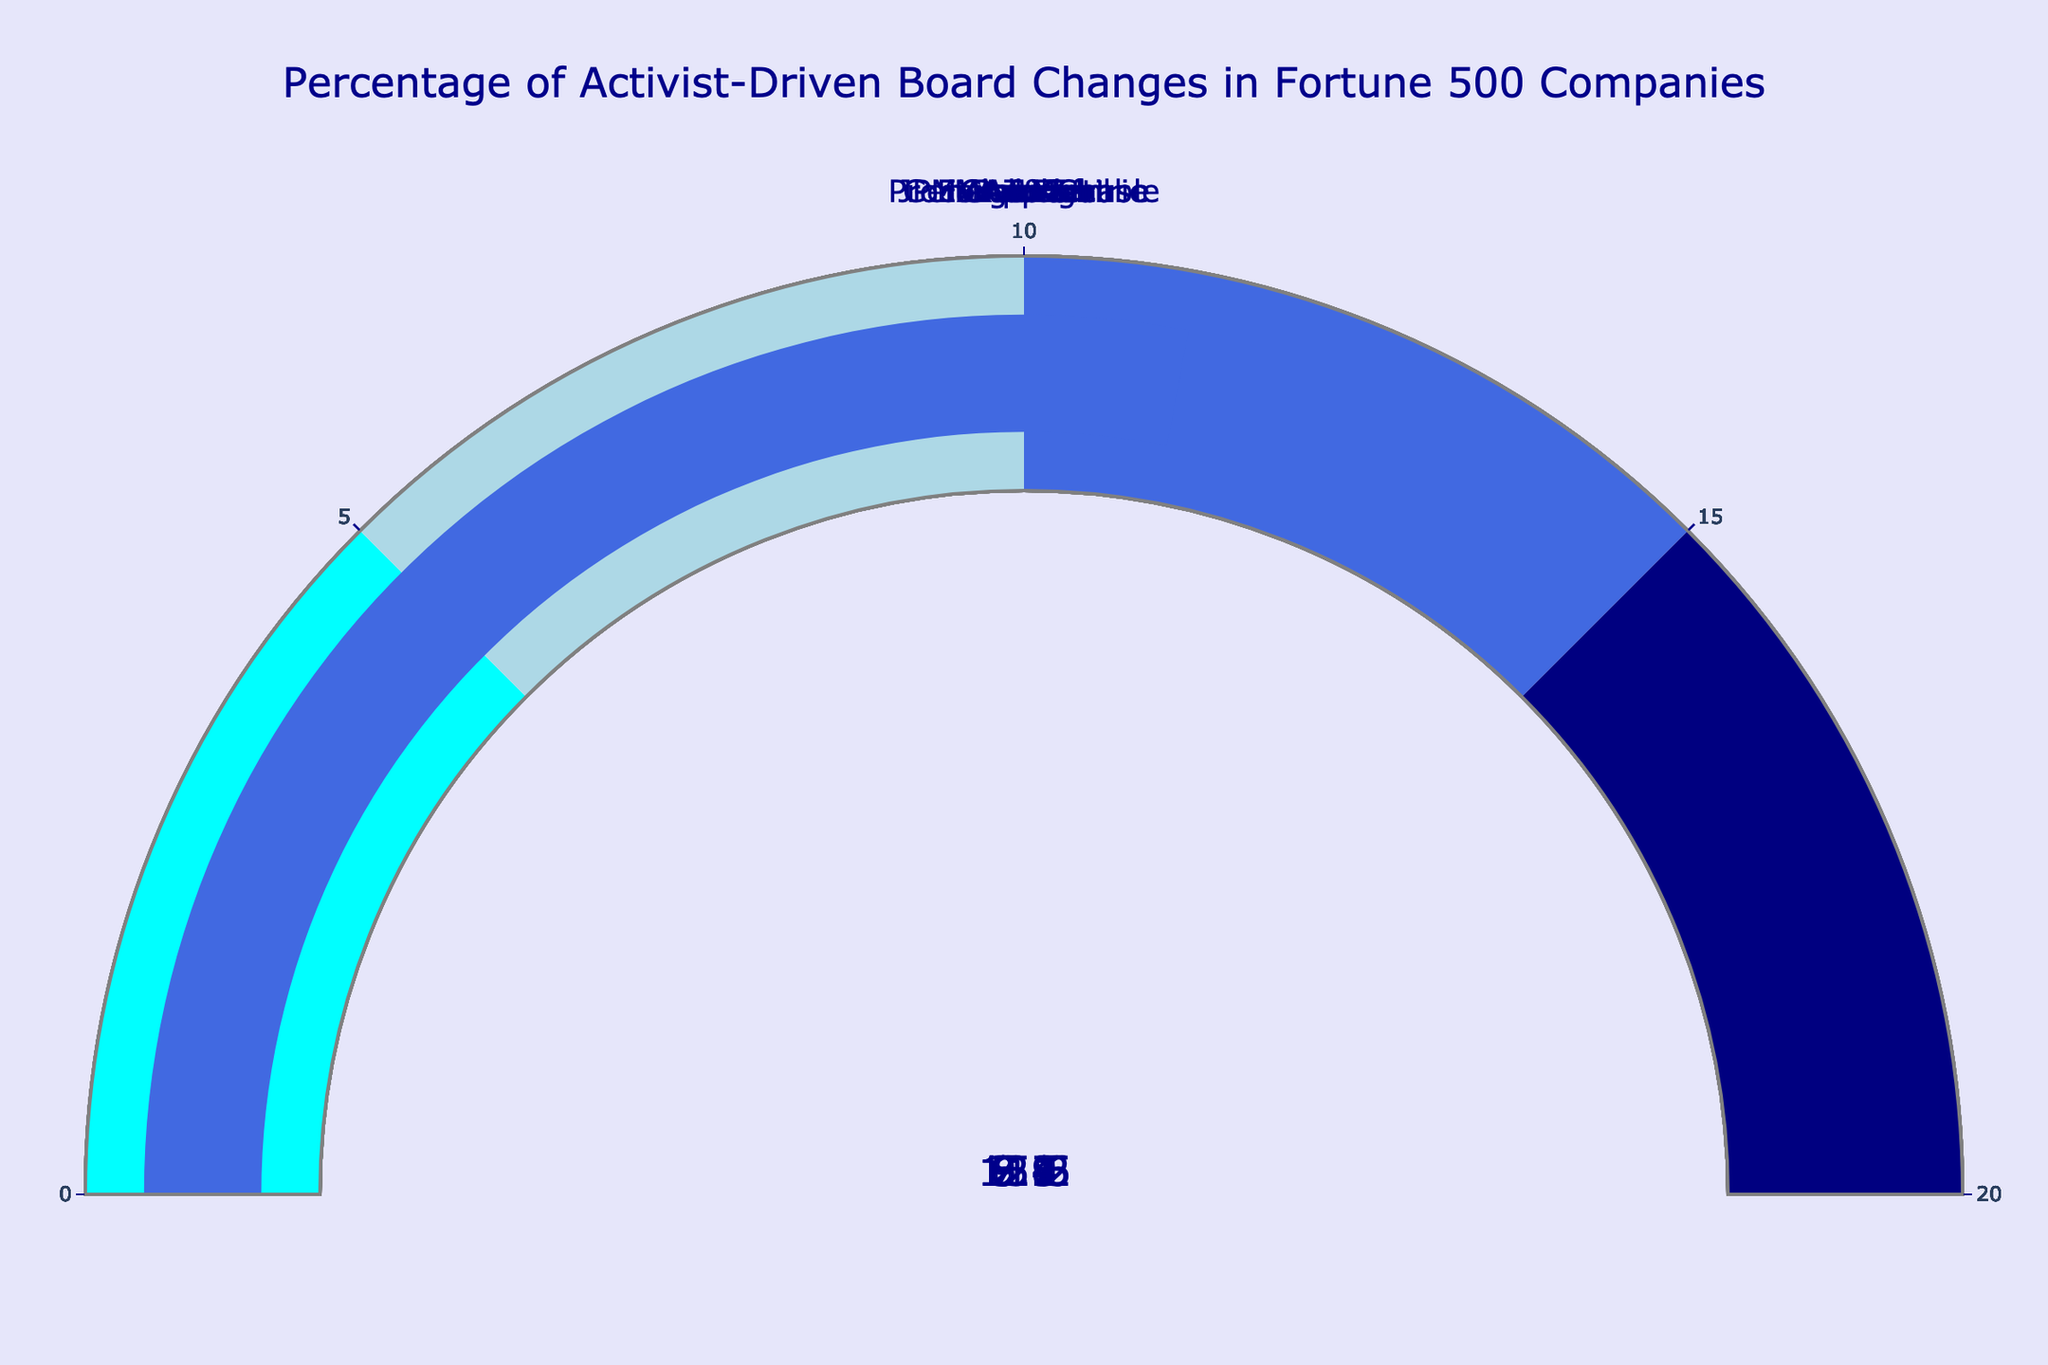How many companies are represented in the gauge chart? The gauge chart displays one gauge per company. Counting the total gauges gives the number of companies.
Answer: 10 What is the title of the gauge chart? The title is displayed prominently at the top of the chart. Reading this title provides the answer.
Answer: Percentage of Activist-Driven Board Changes in Fortune 500 Companies Which company shows the highest percentage of activist-driven board changes? Locate the gauge with the highest value. General Electric has the highest percentage.
Answer: General Electric Which company shows the lowest percentage of activist-driven board changes? Locate the gauge with the lowest value. Microsoft has the lowest percentage.
Answer: Microsoft What is the color of the gauge bar for a percentage between 10 and 15? Analyze the color key on the gauges. The segment for 10-15% is colored royalblue.
Answer: Royalblue What is the average percentage of activist-driven board changes for the companies listed? Add all the percentages and divide by the number of companies. (12.5 + 3.8 + 5.2 + 7.9 + 15.6 + 9.1 + 2.7 + 6.3 + 8.4 + 11.2)/10 = 8.27
Answer: 8.27 Compare ExxonMobil and Walmart. How much higher is ExxonMobil’s percentage of activist-driven board changes? Subtract Walmart's percentage from ExxonMobil's percentage. 12.5 - 5.2 = 7.3
Answer: 7.3 For how many companies is the percentage of activist-driven board changes below 5? Count the gauges that display a value below 5. There are 2 companies: Apple and Microsoft.
Answer: 2 What is the total percentage of activist-driven board changes for JPMorgan Chase, AT&T, and Boeing combined? Add the percentages for JPMorgan Chase, AT&T, and Boeing. 7.9 + 8.4 + 11.2 = 27.5
Answer: 27.5 Which two companies have percentages closest to 10%? Compare values around 10%, look for the two closest. Chevron (9.1) and AT&T (8.4) are closest.
Answer: Chevron and AT&T 